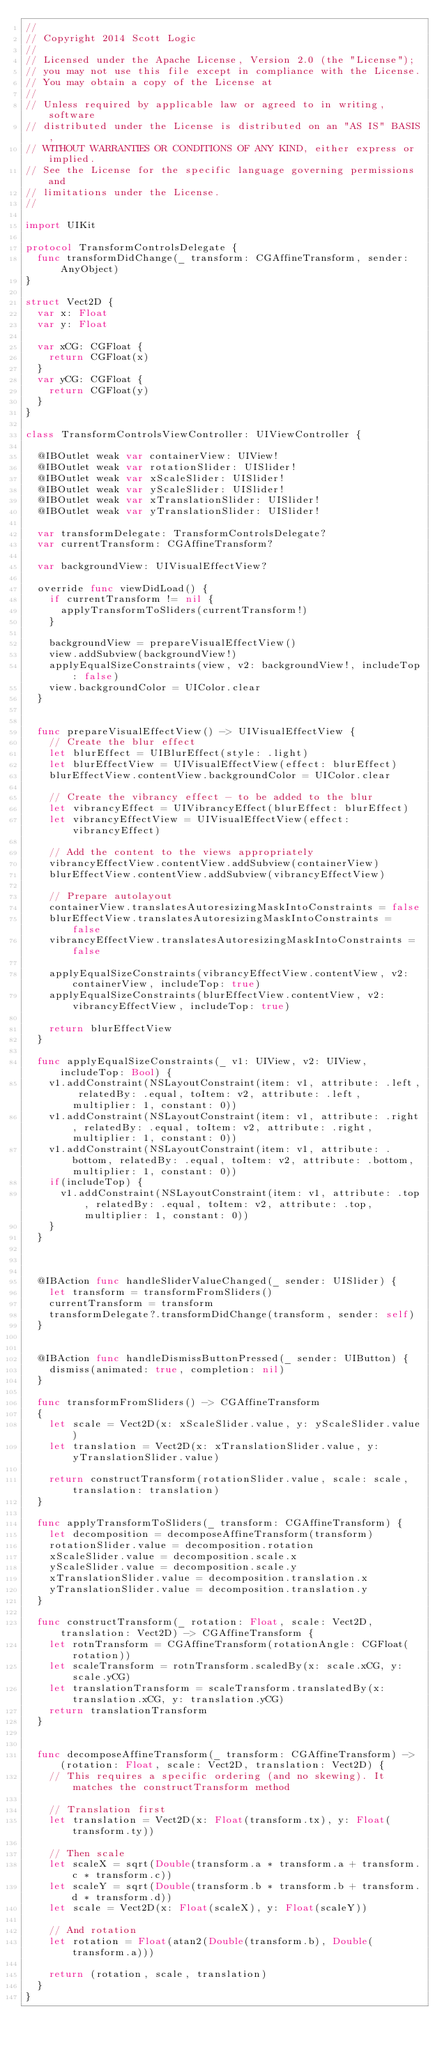<code> <loc_0><loc_0><loc_500><loc_500><_Swift_>//
// Copyright 2014 Scott Logic
//
// Licensed under the Apache License, Version 2.0 (the "License");
// you may not use this file except in compliance with the License.
// You may obtain a copy of the License at
//
// Unless required by applicable law or agreed to in writing, software
// distributed under the License is distributed on an "AS IS" BASIS,
// WITHOUT WARRANTIES OR CONDITIONS OF ANY KIND, either express or implied.
// See the License for the specific language governing permissions and
// limitations under the License.
//

import UIKit

protocol TransformControlsDelegate {
  func transformDidChange(_ transform: CGAffineTransform, sender: AnyObject)
}

struct Vect2D {
  var x: Float
  var y: Float
  
  var xCG: CGFloat {
    return CGFloat(x)
  }
  var yCG: CGFloat {
    return CGFloat(y)
  }
}

class TransformControlsViewController: UIViewController {
  
  @IBOutlet weak var containerView: UIView!
  @IBOutlet weak var rotationSlider: UISlider!
  @IBOutlet weak var xScaleSlider: UISlider!
  @IBOutlet weak var yScaleSlider: UISlider!
  @IBOutlet weak var xTranslationSlider: UISlider!
  @IBOutlet weak var yTranslationSlider: UISlider!
  
  var transformDelegate: TransformControlsDelegate?
  var currentTransform: CGAffineTransform?
  
  var backgroundView: UIVisualEffectView?
  
  override func viewDidLoad() {
    if currentTransform != nil {
      applyTransformToSliders(currentTransform!)
    }
    
    backgroundView = prepareVisualEffectView()
    view.addSubview(backgroundView!)
    applyEqualSizeConstraints(view, v2: backgroundView!, includeTop: false)
    view.backgroundColor = UIColor.clear
  }
  
  
  func prepareVisualEffectView() -> UIVisualEffectView {
    // Create the blur effect
    let blurEffect = UIBlurEffect(style: .light)
    let blurEffectView = UIVisualEffectView(effect: blurEffect)
    blurEffectView.contentView.backgroundColor = UIColor.clear
    
    // Create the vibrancy effect - to be added to the blur
    let vibrancyEffect = UIVibrancyEffect(blurEffect: blurEffect)
    let vibrancyEffectView = UIVisualEffectView(effect: vibrancyEffect)
    
    // Add the content to the views appropriately
    vibrancyEffectView.contentView.addSubview(containerView)
    blurEffectView.contentView.addSubview(vibrancyEffectView)
    
    // Prepare autolayout
    containerView.translatesAutoresizingMaskIntoConstraints = false
    blurEffectView.translatesAutoresizingMaskIntoConstraints = false
    vibrancyEffectView.translatesAutoresizingMaskIntoConstraints = false
    
    applyEqualSizeConstraints(vibrancyEffectView.contentView, v2: containerView, includeTop: true)
    applyEqualSizeConstraints(blurEffectView.contentView, v2: vibrancyEffectView, includeTop: true)
    
    return blurEffectView
  }
  
  func applyEqualSizeConstraints(_ v1: UIView, v2: UIView, includeTop: Bool) {
    v1.addConstraint(NSLayoutConstraint(item: v1, attribute: .left, relatedBy: .equal, toItem: v2, attribute: .left, multiplier: 1, constant: 0))
    v1.addConstraint(NSLayoutConstraint(item: v1, attribute: .right, relatedBy: .equal, toItem: v2, attribute: .right, multiplier: 1, constant: 0))
    v1.addConstraint(NSLayoutConstraint(item: v1, attribute: .bottom, relatedBy: .equal, toItem: v2, attribute: .bottom, multiplier: 1, constant: 0))
    if(includeTop) {
      v1.addConstraint(NSLayoutConstraint(item: v1, attribute: .top, relatedBy: .equal, toItem: v2, attribute: .top, multiplier: 1, constant: 0))
    }
  }
  

  
  @IBAction func handleSliderValueChanged(_ sender: UISlider) {
    let transform = transformFromSliders()
    currentTransform = transform
    transformDelegate?.transformDidChange(transform, sender: self)
  }
  
  
  @IBAction func handleDismissButtonPressed(_ sender: UIButton) {
    dismiss(animated: true, completion: nil)
  }
  
  func transformFromSliders() -> CGAffineTransform
  {
    let scale = Vect2D(x: xScaleSlider.value, y: yScaleSlider.value)
    let translation = Vect2D(x: xTranslationSlider.value, y: yTranslationSlider.value)
    
    return constructTransform(rotationSlider.value, scale: scale, translation: translation)
  }
  
  func applyTransformToSliders(_ transform: CGAffineTransform) {
    let decomposition = decomposeAffineTransform(transform)
    rotationSlider.value = decomposition.rotation
    xScaleSlider.value = decomposition.scale.x
    yScaleSlider.value = decomposition.scale.y
    xTranslationSlider.value = decomposition.translation.x
    yTranslationSlider.value = decomposition.translation.y
  }
  
  func constructTransform(_ rotation: Float, scale: Vect2D, translation: Vect2D) -> CGAffineTransform {
    let rotnTransform = CGAffineTransform(rotationAngle: CGFloat(rotation))
    let scaleTransform = rotnTransform.scaledBy(x: scale.xCG, y: scale.yCG)
    let translationTransform = scaleTransform.translatedBy(x: translation.xCG, y: translation.yCG)
    return translationTransform
  }
  
  
  func decomposeAffineTransform(_ transform: CGAffineTransform) -> (rotation: Float, scale: Vect2D, translation: Vect2D) {
    // This requires a specific ordering (and no skewing). It matches the constructTransform method
    
    // Translation first
    let translation = Vect2D(x: Float(transform.tx), y: Float(transform.ty))
    
    // Then scale
    let scaleX = sqrt(Double(transform.a * transform.a + transform.c * transform.c))
    let scaleY = sqrt(Double(transform.b * transform.b + transform.d * transform.d))
    let scale = Vect2D(x: Float(scaleX), y: Float(scaleY))
    
    // And rotation
    let rotation = Float(atan2(Double(transform.b), Double(transform.a)))
    
    return (rotation, scale, translation)
  }
}

</code> 